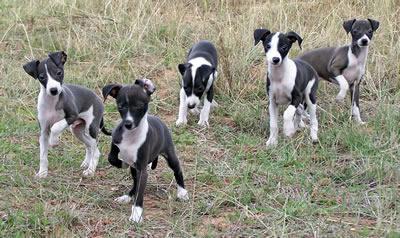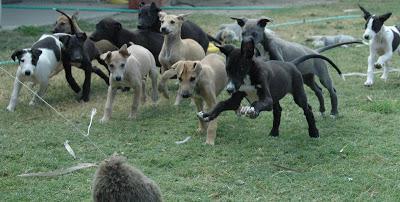The first image is the image on the left, the second image is the image on the right. For the images displayed, is the sentence "One image contains a single dog, which is looking at the camera while in a standing pose indoors." factually correct? Answer yes or no. No. The first image is the image on the left, the second image is the image on the right. Given the left and right images, does the statement "One image contains only one dog, while the other image contains at least 5 dogs." hold true? Answer yes or no. No. 